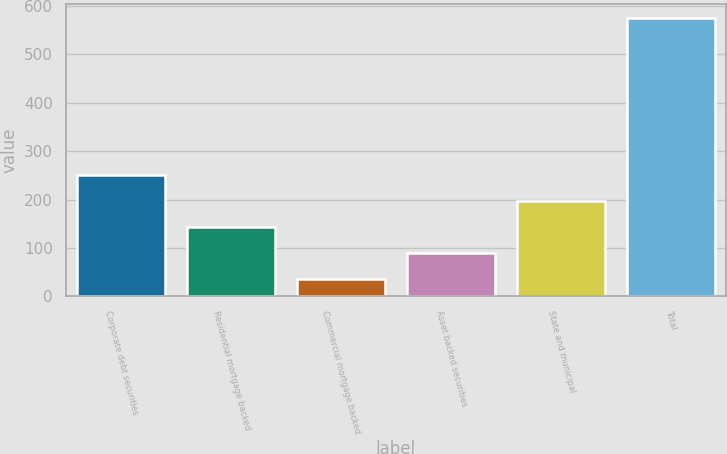Convert chart to OTSL. <chart><loc_0><loc_0><loc_500><loc_500><bar_chart><fcel>Corporate debt securities<fcel>Residential mortgage backed<fcel>Commercial mortgage backed<fcel>Asset backed securities<fcel>State and municipal<fcel>Total<nl><fcel>251.4<fcel>143.2<fcel>35<fcel>89.1<fcel>197.3<fcel>576<nl></chart> 